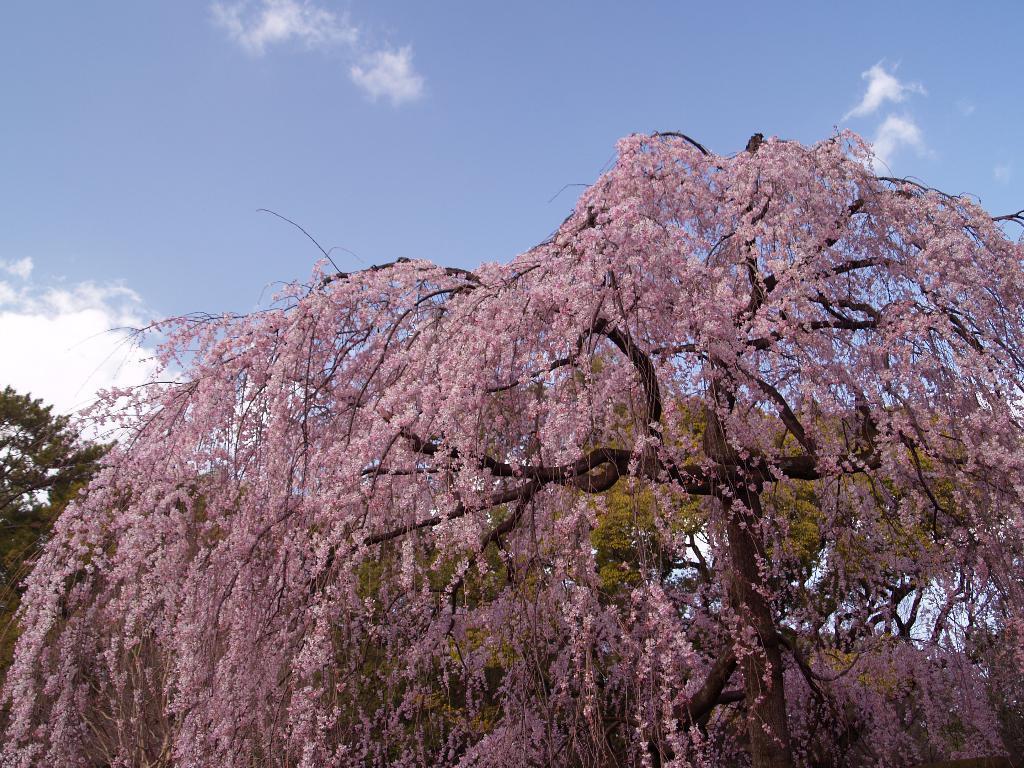Describe this image in one or two sentences. In this picture we can see flowers in the front, in the background there are trees, we can see the sky at the top of the picture. 